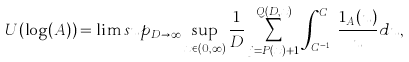Convert formula to latex. <formula><loc_0><loc_0><loc_500><loc_500>U ( \log ( A ) ) = \lim s u p _ { D \rightarrow \infty } \sup _ { x \in ( 0 , \infty ) } \frac { 1 } { D } \sum _ { j = P ( x ) + 1 } ^ { Q ( D , x ) } \int _ { C ^ { j - 1 } } ^ { C ^ { j } } \frac { 1 _ { A } ( u ) } { u } d u ,</formula> 